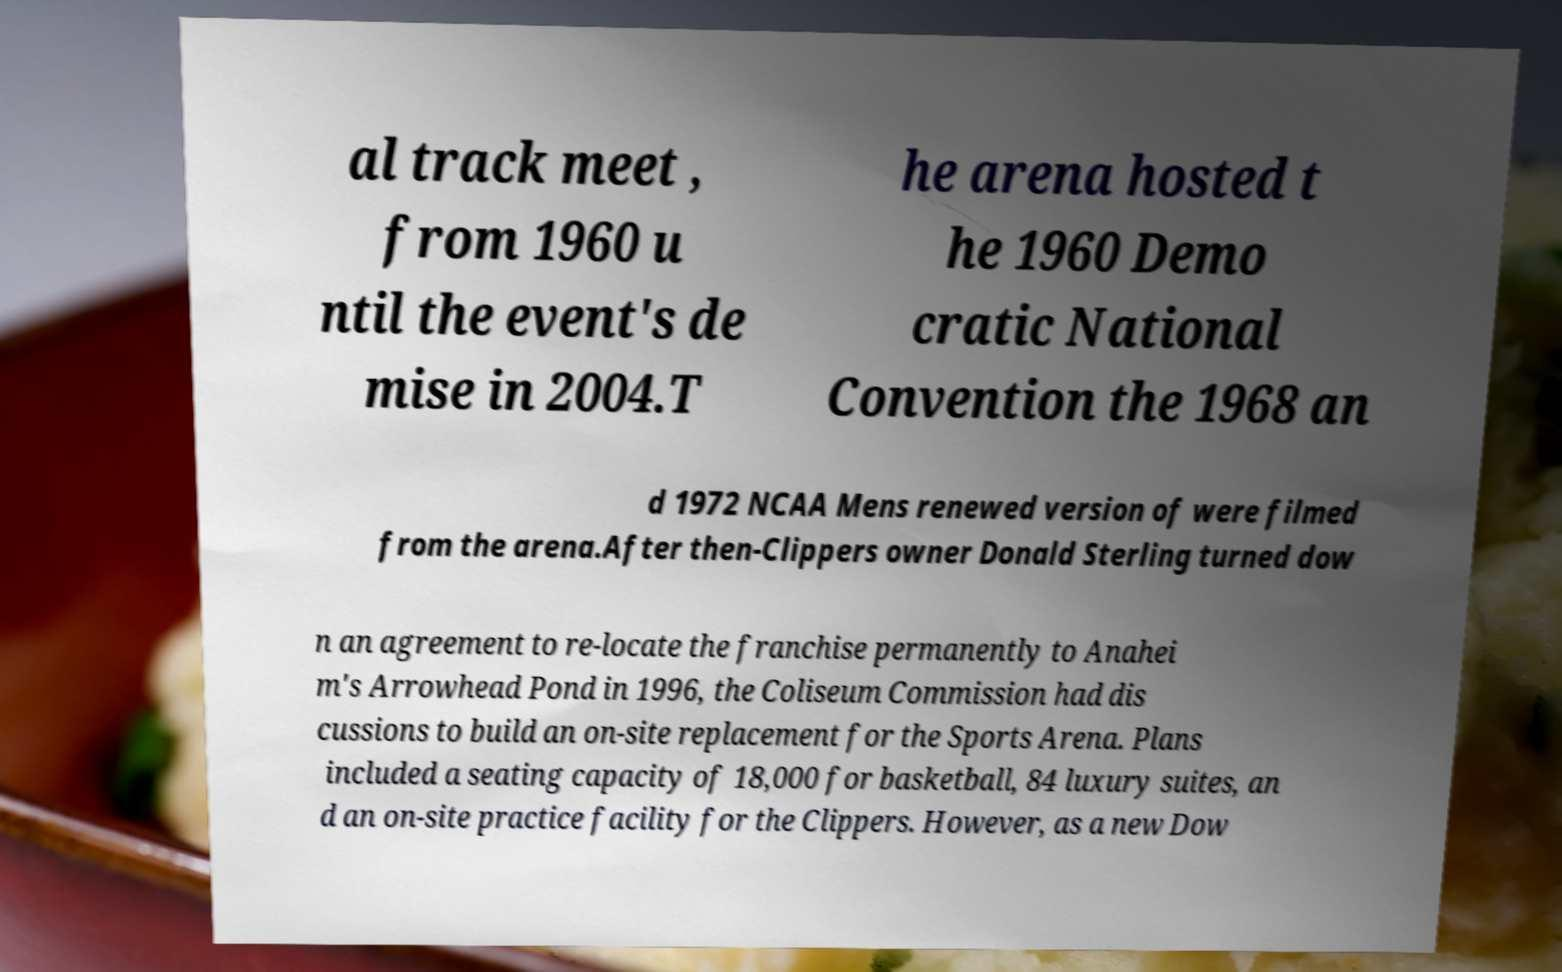Can you read and provide the text displayed in the image?This photo seems to have some interesting text. Can you extract and type it out for me? al track meet , from 1960 u ntil the event's de mise in 2004.T he arena hosted t he 1960 Demo cratic National Convention the 1968 an d 1972 NCAA Mens renewed version of were filmed from the arena.After then-Clippers owner Donald Sterling turned dow n an agreement to re-locate the franchise permanently to Anahei m's Arrowhead Pond in 1996, the Coliseum Commission had dis cussions to build an on-site replacement for the Sports Arena. Plans included a seating capacity of 18,000 for basketball, 84 luxury suites, an d an on-site practice facility for the Clippers. However, as a new Dow 